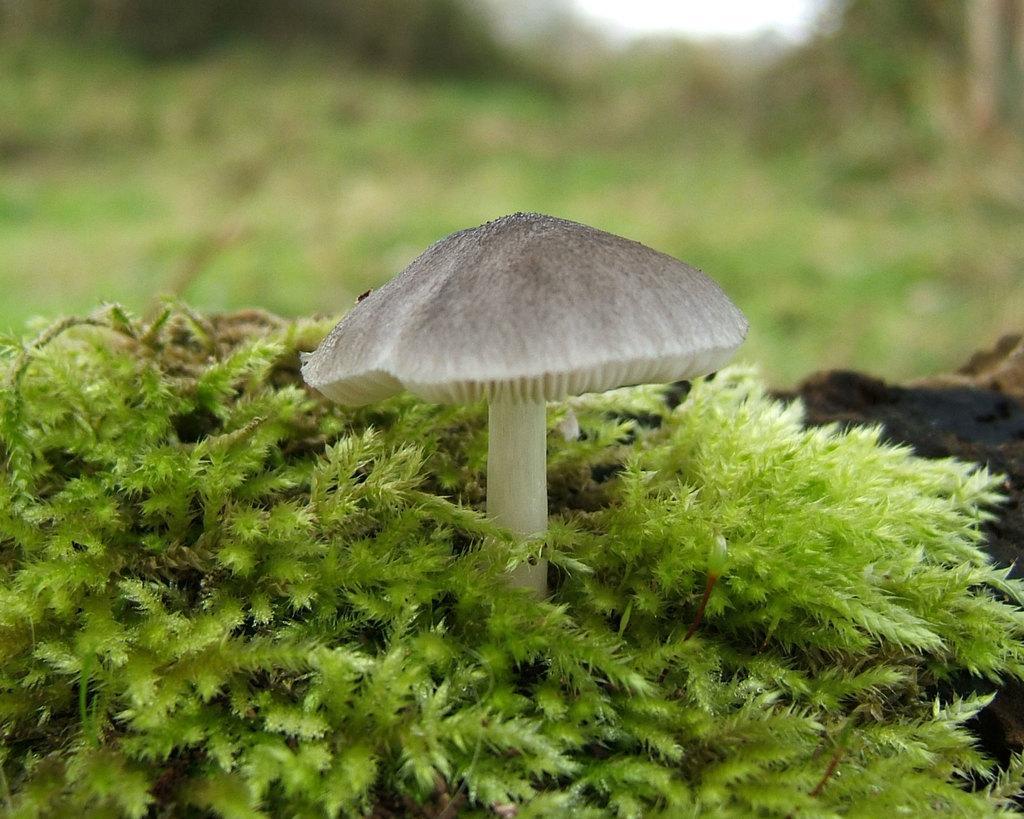How would you summarize this image in a sentence or two? Here we can see plants and mushroom. Background it is blur. 